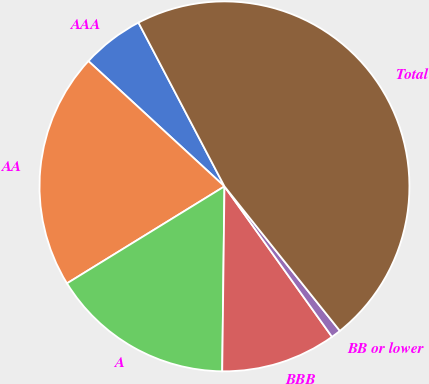Convert chart. <chart><loc_0><loc_0><loc_500><loc_500><pie_chart><fcel>AAA<fcel>AA<fcel>A<fcel>BBB<fcel>BB or lower<fcel>Total<nl><fcel>5.46%<fcel>20.63%<fcel>16.02%<fcel>10.07%<fcel>0.85%<fcel>46.97%<nl></chart> 